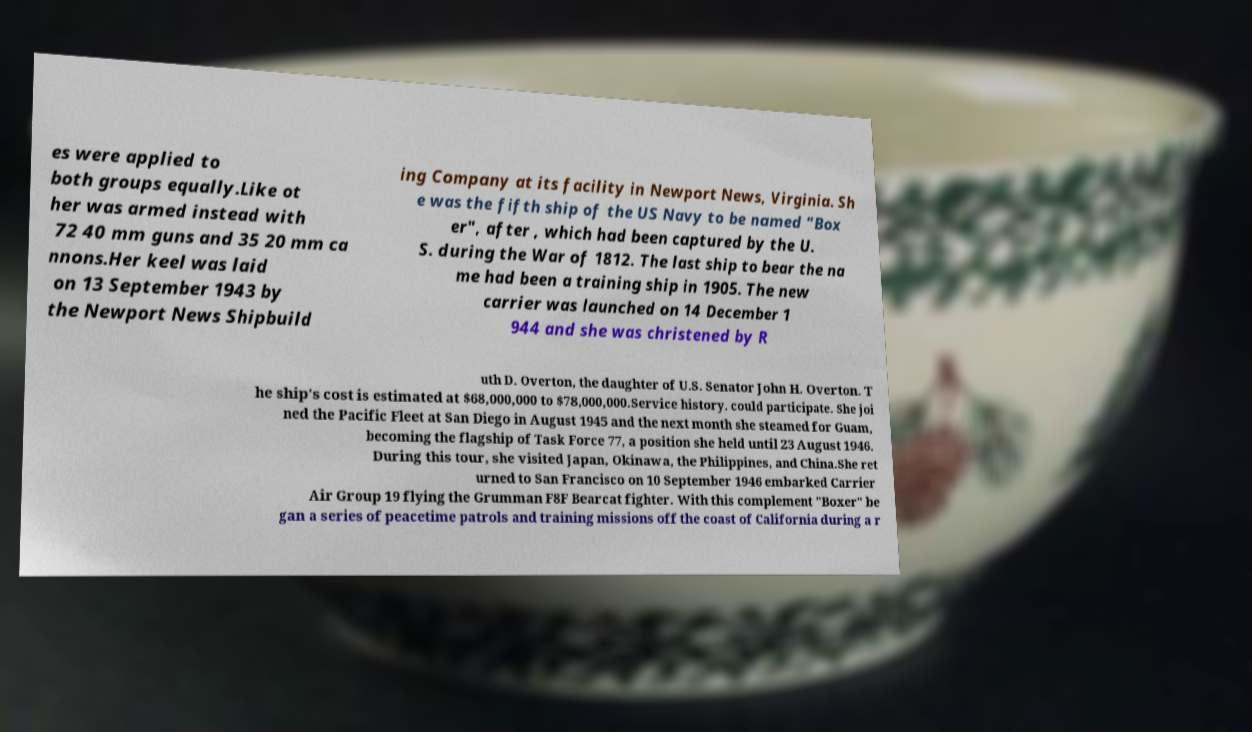Could you extract and type out the text from this image? es were applied to both groups equally.Like ot her was armed instead with 72 40 mm guns and 35 20 mm ca nnons.Her keel was laid on 13 September 1943 by the Newport News Shipbuild ing Company at its facility in Newport News, Virginia. Sh e was the fifth ship of the US Navy to be named "Box er", after , which had been captured by the U. S. during the War of 1812. The last ship to bear the na me had been a training ship in 1905. The new carrier was launched on 14 December 1 944 and she was christened by R uth D. Overton, the daughter of U.S. Senator John H. Overton. T he ship's cost is estimated at $68,000,000 to $78,000,000.Service history. could participate. She joi ned the Pacific Fleet at San Diego in August 1945 and the next month she steamed for Guam, becoming the flagship of Task Force 77, a position she held until 23 August 1946. During this tour, she visited Japan, Okinawa, the Philippines, and China.She ret urned to San Francisco on 10 September 1946 embarked Carrier Air Group 19 flying the Grumman F8F Bearcat fighter. With this complement "Boxer" be gan a series of peacetime patrols and training missions off the coast of California during a r 